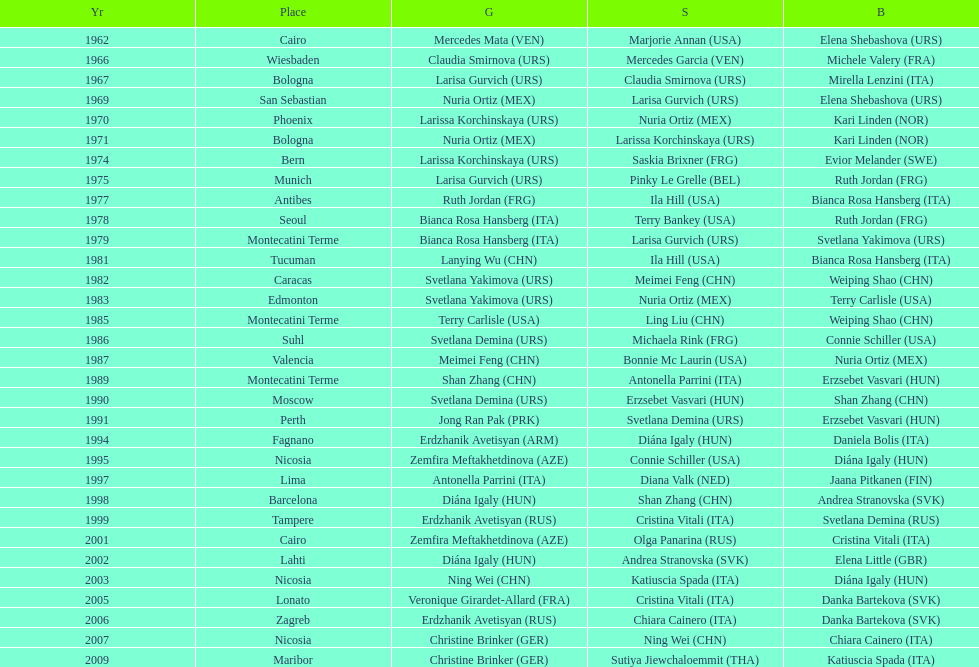What is the total amount of winnings for the united states in gold, silver and bronze? 9. 